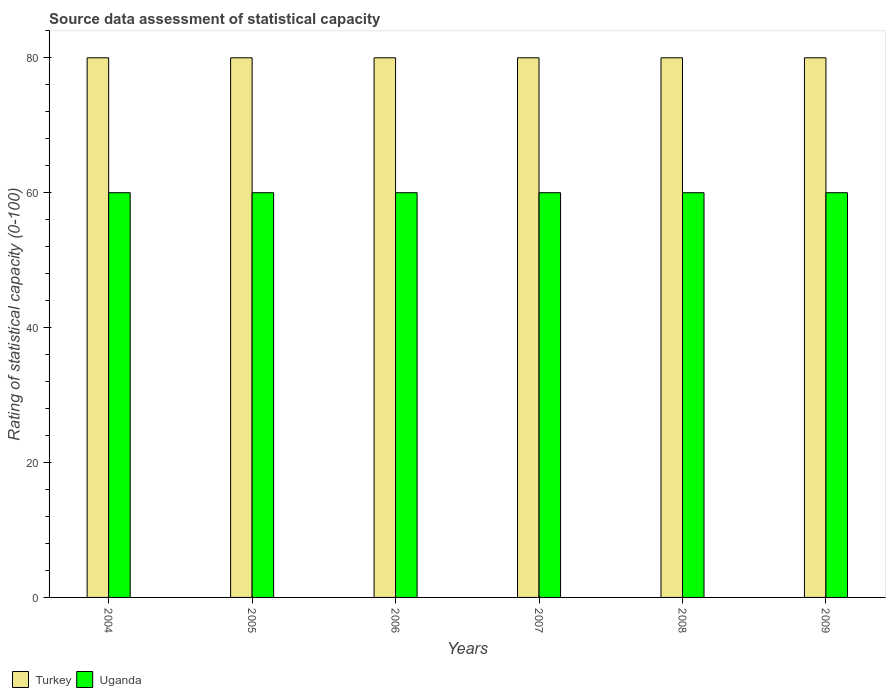How many groups of bars are there?
Give a very brief answer. 6. What is the label of the 4th group of bars from the left?
Offer a very short reply. 2007. In how many cases, is the number of bars for a given year not equal to the number of legend labels?
Make the answer very short. 0. What is the rating of statistical capacity in Turkey in 2008?
Keep it short and to the point. 80. Across all years, what is the maximum rating of statistical capacity in Uganda?
Make the answer very short. 60. Across all years, what is the minimum rating of statistical capacity in Uganda?
Make the answer very short. 60. In which year was the rating of statistical capacity in Uganda maximum?
Offer a terse response. 2004. In which year was the rating of statistical capacity in Uganda minimum?
Offer a very short reply. 2004. What is the total rating of statistical capacity in Uganda in the graph?
Offer a terse response. 360. What is the difference between the rating of statistical capacity in Turkey in 2008 and that in 2009?
Your answer should be compact. 0. What is the difference between the rating of statistical capacity in Turkey in 2006 and the rating of statistical capacity in Uganda in 2004?
Your response must be concise. 20. In the year 2007, what is the difference between the rating of statistical capacity in Uganda and rating of statistical capacity in Turkey?
Keep it short and to the point. -20. In how many years, is the rating of statistical capacity in Turkey greater than 20?
Provide a succinct answer. 6. What is the difference between the highest and the lowest rating of statistical capacity in Uganda?
Keep it short and to the point. 0. What does the 1st bar from the left in 2009 represents?
Give a very brief answer. Turkey. What does the 2nd bar from the right in 2007 represents?
Offer a very short reply. Turkey. How many years are there in the graph?
Offer a terse response. 6. Does the graph contain any zero values?
Keep it short and to the point. No. Where does the legend appear in the graph?
Provide a short and direct response. Bottom left. How many legend labels are there?
Offer a terse response. 2. How are the legend labels stacked?
Offer a very short reply. Horizontal. What is the title of the graph?
Provide a succinct answer. Source data assessment of statistical capacity. What is the label or title of the Y-axis?
Offer a very short reply. Rating of statistical capacity (0-100). What is the Rating of statistical capacity (0-100) of Turkey in 2004?
Give a very brief answer. 80. What is the Rating of statistical capacity (0-100) in Turkey in 2006?
Offer a very short reply. 80. What is the Rating of statistical capacity (0-100) of Uganda in 2006?
Your response must be concise. 60. What is the Rating of statistical capacity (0-100) of Uganda in 2007?
Your response must be concise. 60. What is the Rating of statistical capacity (0-100) in Turkey in 2008?
Make the answer very short. 80. What is the Rating of statistical capacity (0-100) of Uganda in 2008?
Your answer should be compact. 60. Across all years, what is the minimum Rating of statistical capacity (0-100) in Turkey?
Offer a terse response. 80. Across all years, what is the minimum Rating of statistical capacity (0-100) of Uganda?
Make the answer very short. 60. What is the total Rating of statistical capacity (0-100) of Turkey in the graph?
Make the answer very short. 480. What is the total Rating of statistical capacity (0-100) of Uganda in the graph?
Your response must be concise. 360. What is the difference between the Rating of statistical capacity (0-100) of Uganda in 2004 and that in 2005?
Your answer should be very brief. 0. What is the difference between the Rating of statistical capacity (0-100) of Turkey in 2004 and that in 2006?
Your answer should be compact. 0. What is the difference between the Rating of statistical capacity (0-100) of Uganda in 2004 and that in 2006?
Give a very brief answer. 0. What is the difference between the Rating of statistical capacity (0-100) in Uganda in 2004 and that in 2007?
Give a very brief answer. 0. What is the difference between the Rating of statistical capacity (0-100) in Turkey in 2004 and that in 2008?
Offer a terse response. 0. What is the difference between the Rating of statistical capacity (0-100) in Turkey in 2004 and that in 2009?
Provide a succinct answer. 0. What is the difference between the Rating of statistical capacity (0-100) in Uganda in 2005 and that in 2006?
Provide a short and direct response. 0. What is the difference between the Rating of statistical capacity (0-100) in Uganda in 2005 and that in 2007?
Your answer should be compact. 0. What is the difference between the Rating of statistical capacity (0-100) in Uganda in 2005 and that in 2009?
Offer a very short reply. 0. What is the difference between the Rating of statistical capacity (0-100) in Turkey in 2006 and that in 2009?
Provide a succinct answer. 0. What is the difference between the Rating of statistical capacity (0-100) of Turkey in 2007 and that in 2008?
Give a very brief answer. 0. What is the difference between the Rating of statistical capacity (0-100) of Uganda in 2008 and that in 2009?
Ensure brevity in your answer.  0. What is the difference between the Rating of statistical capacity (0-100) of Turkey in 2004 and the Rating of statistical capacity (0-100) of Uganda in 2006?
Your answer should be compact. 20. What is the difference between the Rating of statistical capacity (0-100) in Turkey in 2004 and the Rating of statistical capacity (0-100) in Uganda in 2007?
Provide a short and direct response. 20. What is the difference between the Rating of statistical capacity (0-100) in Turkey in 2004 and the Rating of statistical capacity (0-100) in Uganda in 2009?
Give a very brief answer. 20. What is the difference between the Rating of statistical capacity (0-100) of Turkey in 2005 and the Rating of statistical capacity (0-100) of Uganda in 2006?
Your response must be concise. 20. What is the difference between the Rating of statistical capacity (0-100) of Turkey in 2005 and the Rating of statistical capacity (0-100) of Uganda in 2007?
Your response must be concise. 20. What is the difference between the Rating of statistical capacity (0-100) of Turkey in 2006 and the Rating of statistical capacity (0-100) of Uganda in 2007?
Offer a terse response. 20. What is the difference between the Rating of statistical capacity (0-100) in Turkey in 2006 and the Rating of statistical capacity (0-100) in Uganda in 2009?
Your response must be concise. 20. What is the difference between the Rating of statistical capacity (0-100) of Turkey in 2008 and the Rating of statistical capacity (0-100) of Uganda in 2009?
Your response must be concise. 20. What is the average Rating of statistical capacity (0-100) of Uganda per year?
Offer a very short reply. 60. In the year 2004, what is the difference between the Rating of statistical capacity (0-100) in Turkey and Rating of statistical capacity (0-100) in Uganda?
Offer a terse response. 20. In the year 2008, what is the difference between the Rating of statistical capacity (0-100) in Turkey and Rating of statistical capacity (0-100) in Uganda?
Keep it short and to the point. 20. What is the ratio of the Rating of statistical capacity (0-100) in Uganda in 2004 to that in 2005?
Your response must be concise. 1. What is the ratio of the Rating of statistical capacity (0-100) in Turkey in 2004 to that in 2006?
Keep it short and to the point. 1. What is the ratio of the Rating of statistical capacity (0-100) in Uganda in 2004 to that in 2006?
Offer a very short reply. 1. What is the ratio of the Rating of statistical capacity (0-100) of Turkey in 2004 to that in 2007?
Offer a very short reply. 1. What is the ratio of the Rating of statistical capacity (0-100) of Uganda in 2004 to that in 2007?
Your response must be concise. 1. What is the ratio of the Rating of statistical capacity (0-100) in Turkey in 2004 to that in 2009?
Your answer should be compact. 1. What is the ratio of the Rating of statistical capacity (0-100) in Turkey in 2005 to that in 2006?
Offer a terse response. 1. What is the ratio of the Rating of statistical capacity (0-100) of Uganda in 2005 to that in 2006?
Give a very brief answer. 1. What is the ratio of the Rating of statistical capacity (0-100) in Turkey in 2005 to that in 2007?
Ensure brevity in your answer.  1. What is the ratio of the Rating of statistical capacity (0-100) in Uganda in 2005 to that in 2007?
Ensure brevity in your answer.  1. What is the ratio of the Rating of statistical capacity (0-100) of Uganda in 2005 to that in 2008?
Provide a succinct answer. 1. What is the ratio of the Rating of statistical capacity (0-100) in Turkey in 2006 to that in 2007?
Your answer should be very brief. 1. What is the ratio of the Rating of statistical capacity (0-100) of Uganda in 2006 to that in 2008?
Make the answer very short. 1. What is the ratio of the Rating of statistical capacity (0-100) of Turkey in 2006 to that in 2009?
Make the answer very short. 1. What is the ratio of the Rating of statistical capacity (0-100) of Uganda in 2007 to that in 2008?
Keep it short and to the point. 1. What is the ratio of the Rating of statistical capacity (0-100) of Turkey in 2007 to that in 2009?
Provide a short and direct response. 1. What is the difference between the highest and the second highest Rating of statistical capacity (0-100) of Turkey?
Make the answer very short. 0. What is the difference between the highest and the second highest Rating of statistical capacity (0-100) in Uganda?
Your response must be concise. 0. What is the difference between the highest and the lowest Rating of statistical capacity (0-100) of Uganda?
Make the answer very short. 0. 